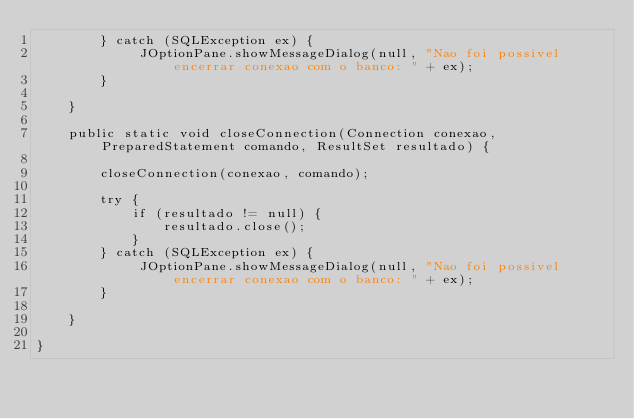Convert code to text. <code><loc_0><loc_0><loc_500><loc_500><_Java_>        } catch (SQLException ex) {
             JOptionPane.showMessageDialog(null, "Nao foi possivel encerrar conexao com o banco: " + ex);
        }

    }

    public static void closeConnection(Connection conexao, PreparedStatement comando, ResultSet resultado) {

        closeConnection(conexao, comando);

        try {
            if (resultado != null) {
                resultado.close();
            }
        } catch (SQLException ex) {
             JOptionPane.showMessageDialog(null, "Nao foi possivel encerrar conexao com o banco: " + ex);
        }

    }

}
</code> 